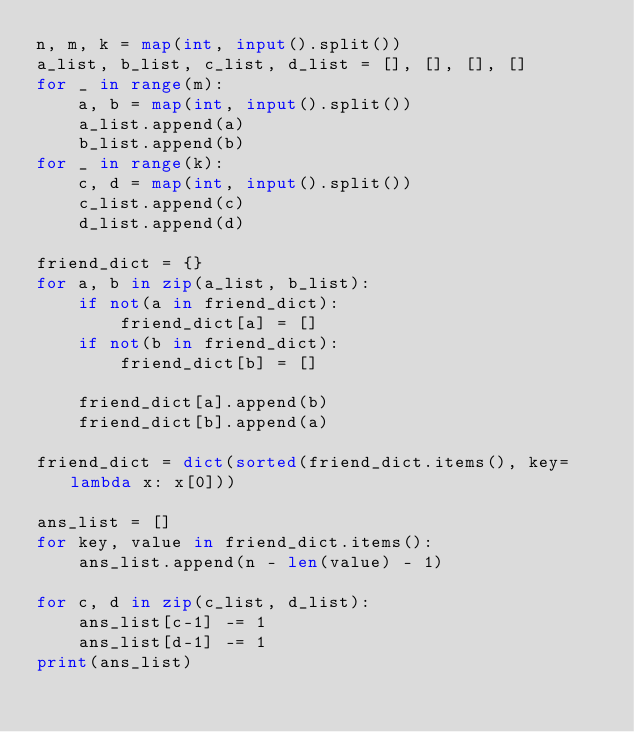Convert code to text. <code><loc_0><loc_0><loc_500><loc_500><_Python_>n, m, k = map(int, input().split())
a_list, b_list, c_list, d_list = [], [], [], []
for _ in range(m):
    a, b = map(int, input().split())
    a_list.append(a)
    b_list.append(b)
for _ in range(k):
    c, d = map(int, input().split())
    c_list.append(c)
    d_list.append(d)

friend_dict = {}
for a, b in zip(a_list, b_list):
    if not(a in friend_dict):
        friend_dict[a] = []
    if not(b in friend_dict):
        friend_dict[b] = []

    friend_dict[a].append(b)
    friend_dict[b].append(a)

friend_dict = dict(sorted(friend_dict.items(), key=lambda x: x[0]))

ans_list = []
for key, value in friend_dict.items():
    ans_list.append(n - len(value) - 1)

for c, d in zip(c_list, d_list):
    ans_list[c-1] -= 1
    ans_list[d-1] -= 1
print(ans_list)
</code> 